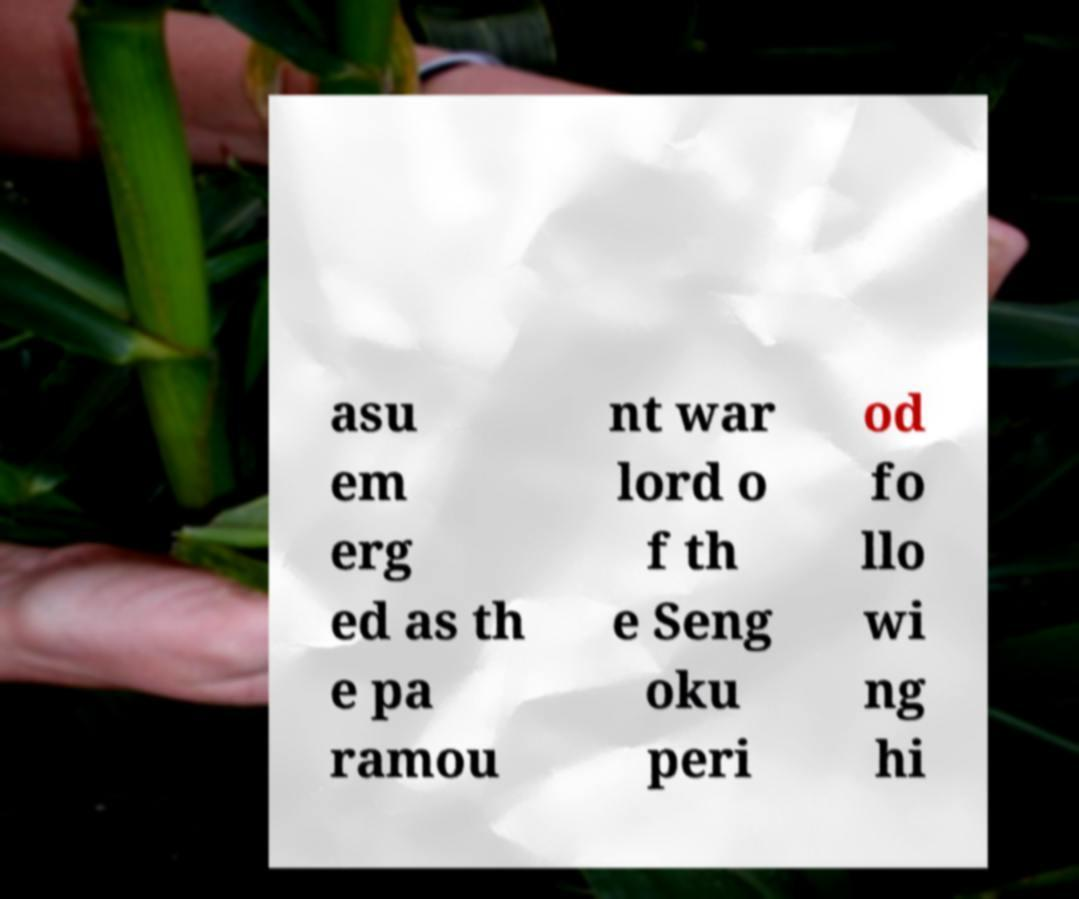For documentation purposes, I need the text within this image transcribed. Could you provide that? asu em erg ed as th e pa ramou nt war lord o f th e Seng oku peri od fo llo wi ng hi 